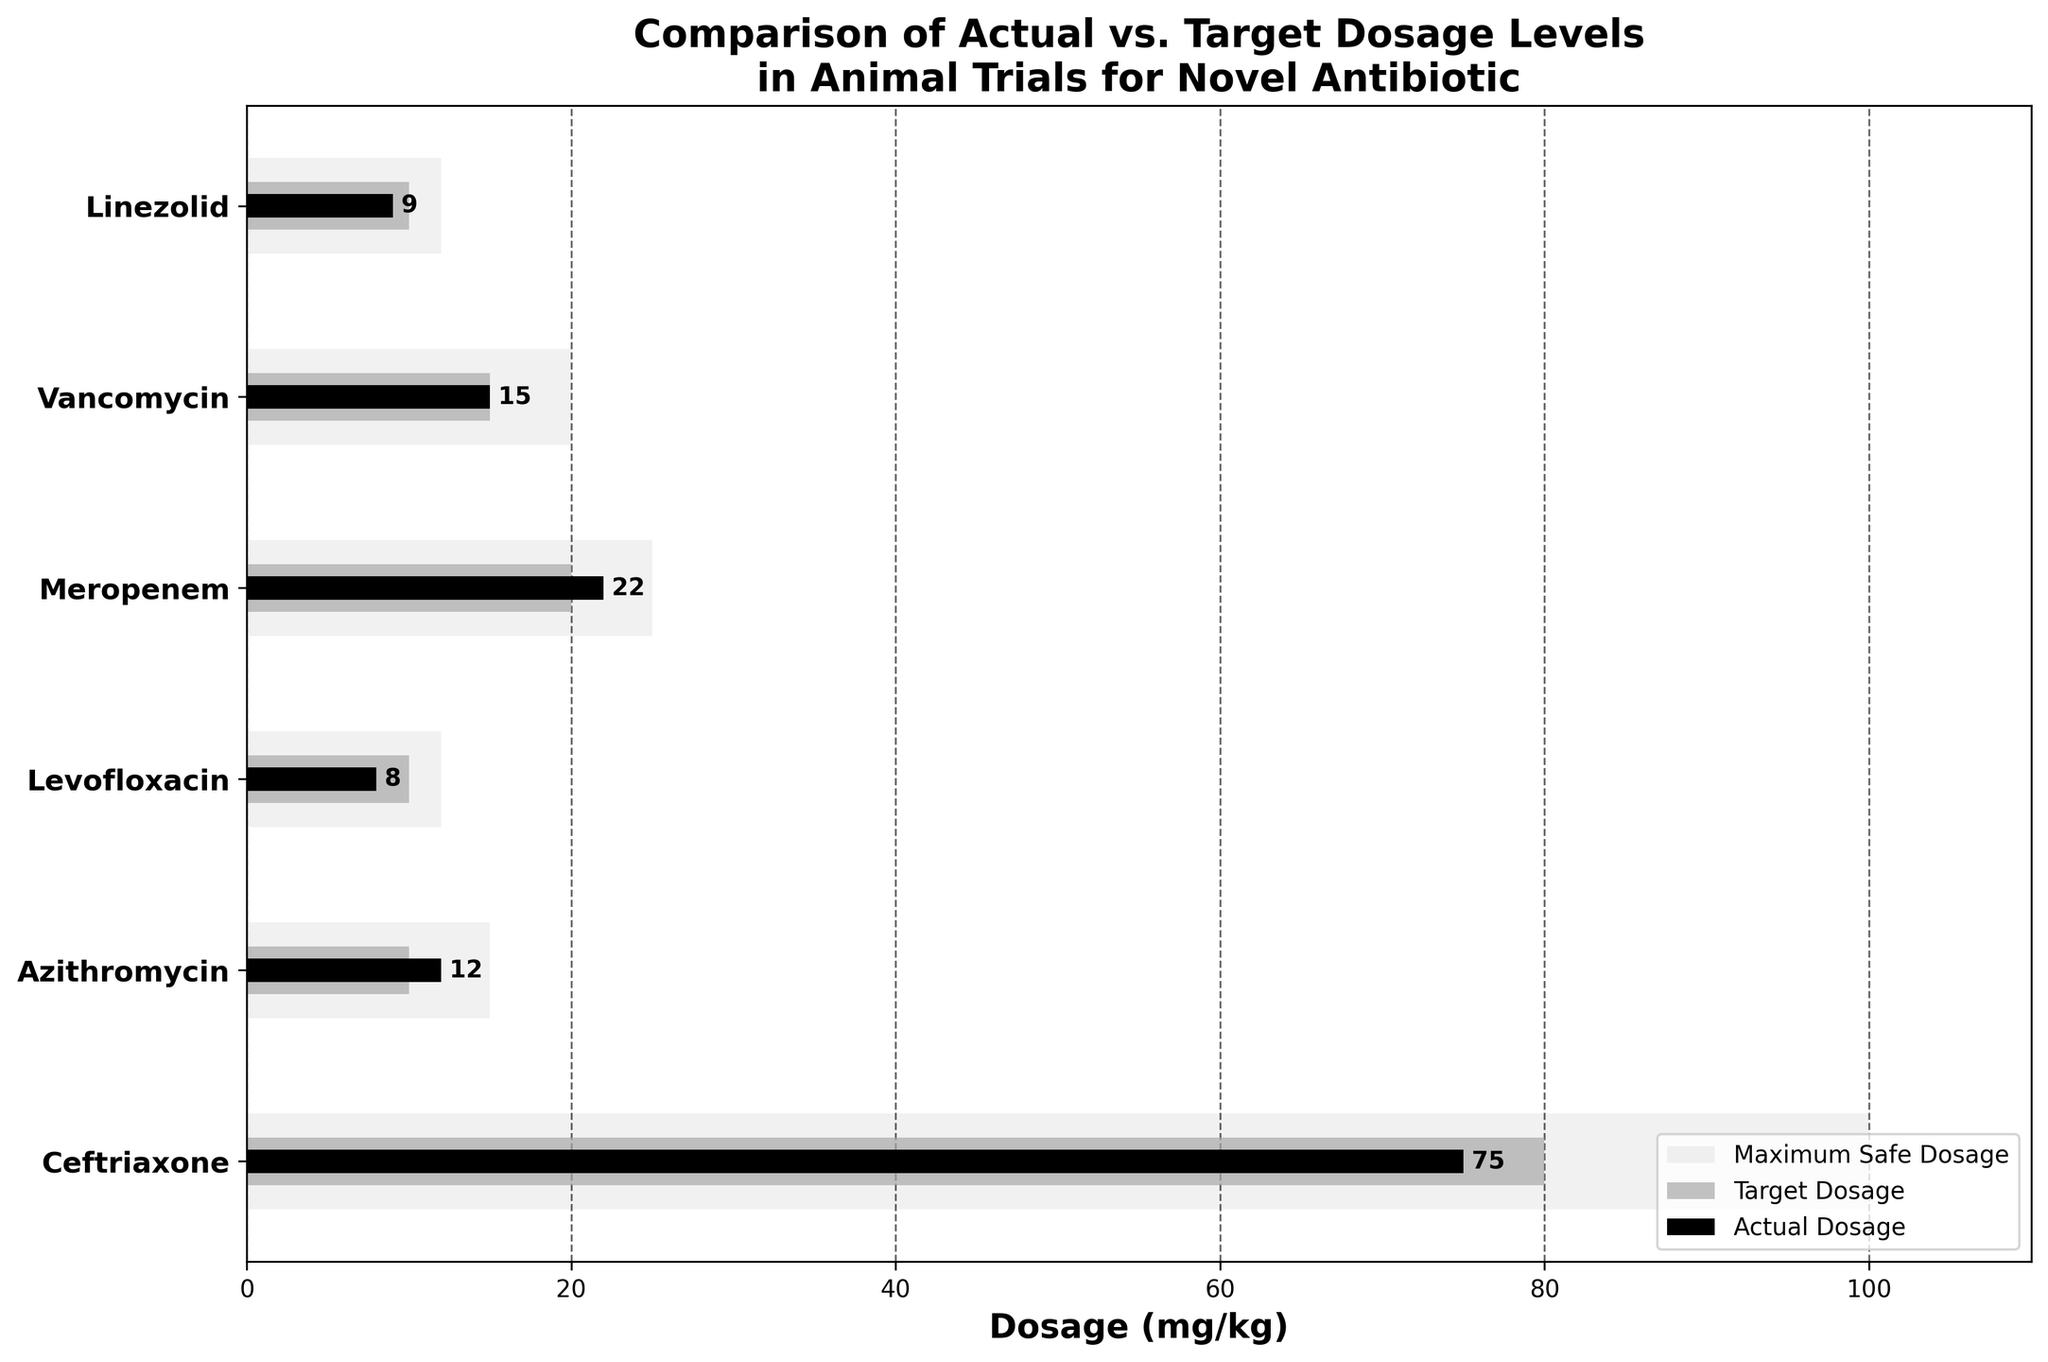How many different drugs are compared in the figure? Count the number of unique drugs listed on the y-axis. There are six drugs compared: Ceftriaxone, Azithromycin, Levofloxacin, Meropenem, Vancomycin, and Linezolid.
Answer: Six What is the title of the figure? The title is prominently displayed at the top of the figure. It reads "Comparison of Actual vs. Target Dosage Levels in Animal Trials for Novel Antibiotic."
Answer: Comparison of Actual vs. Target Dosage Levels in Animal Trials for Novel Antibiotic Which drug has the highest actual dosage level? Locate the highest value on the actual dosage bars and check the corresponding drug on the y-axis. Ceftriaxone has the highest actual dosage level at 75 mg/kg.
Answer: Ceftriaxone How much higher is Ceftriaxone's actual dosage compared to its target dosage? Subtract the target dosage of Ceftriaxone from its actual dosage (75 - 80 = -5 mg/kg). Ceftriaxone's actual dosage is 5 mg/kg lower than the target dosage.
Answer: 5 mg/kg lower Is the actual dosage of Vancomycin equal to, greater than, or less than its target dosage? Compare the lengths of the actual dosage bar for Vancomycin to its target dosage bar. Both bars are equal in length, indicating the actual dosage is equal to the target dosage.
Answer: Equal Which drug's actual dosage exceeds its target dosage? Check the actual dosage bars that extend beyond the target dosage bars. Azithromycin's actual dosage (12 mg/kg) exceeds the target (10 mg/kg).
Answer: Azithromycin What range does the x-axis cover? Observe the axis labels on the x-axis to determine its range. The x-axis ranges from 0 to a little beyond the maximum safe dosage value, so approximately 0 to 110 mg/kg.
Answer: 0 to 110 mg/kg Which drugs have actual dosages within their maximum safe dosages? Compare the actual dosage bars with the background maximum safe dosage bars. All drugs have actual dosages within their respective maximum safe dosages.
Answer: All drugs What's the average target dosage across all drugs? Add the target dosages of all drugs and divide by the number of drugs: (80 + 10 + 10 + 20 + 15 + 10) / 6 = 145 / 6 = ~24.17 mg/kg.
Answer: ~24.17 mg/kg 